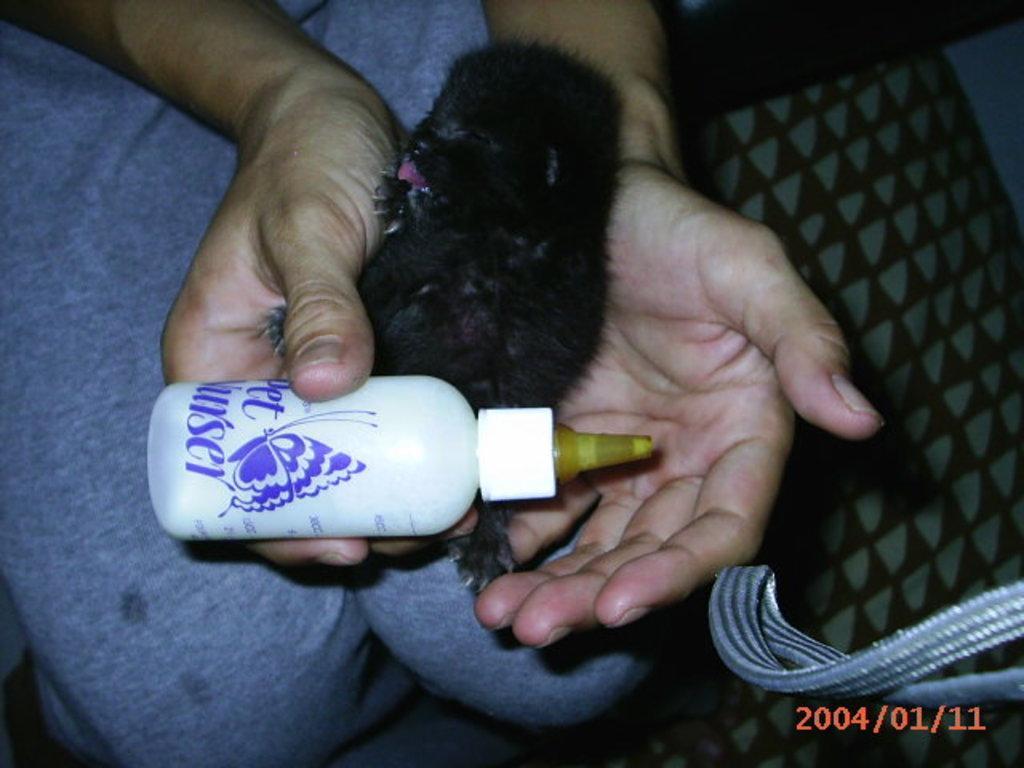Can you describe this image briefly? In this image we can see a small black color dog is in the hands of a person. There is also a milk bottle in his hands. 